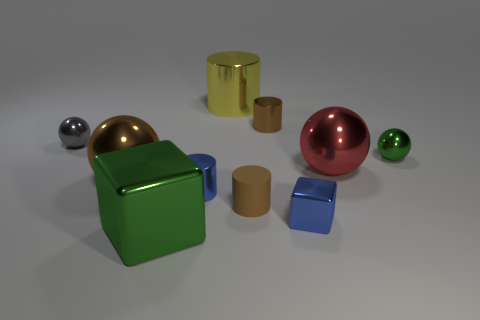Subtract 1 cylinders. How many cylinders are left? 3 Subtract all gray cylinders. Subtract all cyan spheres. How many cylinders are left? 4 Subtract all spheres. How many objects are left? 6 Add 1 small brown rubber things. How many small brown rubber things exist? 2 Subtract 1 blue cylinders. How many objects are left? 9 Subtract all spheres. Subtract all small purple rubber spheres. How many objects are left? 6 Add 9 tiny brown rubber things. How many tiny brown rubber things are left? 10 